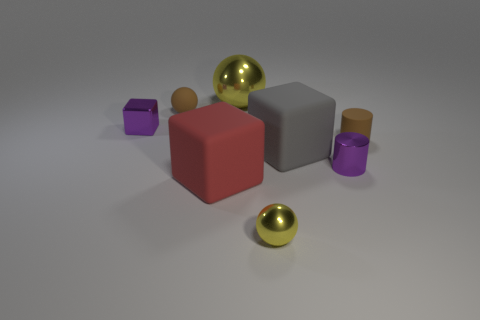Add 1 brown cylinders. How many objects exist? 9 Subtract all cylinders. How many objects are left? 6 Add 2 large red cubes. How many large red cubes are left? 3 Add 8 small matte cylinders. How many small matte cylinders exist? 9 Subtract 0 green cylinders. How many objects are left? 8 Subtract all metal cylinders. Subtract all cubes. How many objects are left? 4 